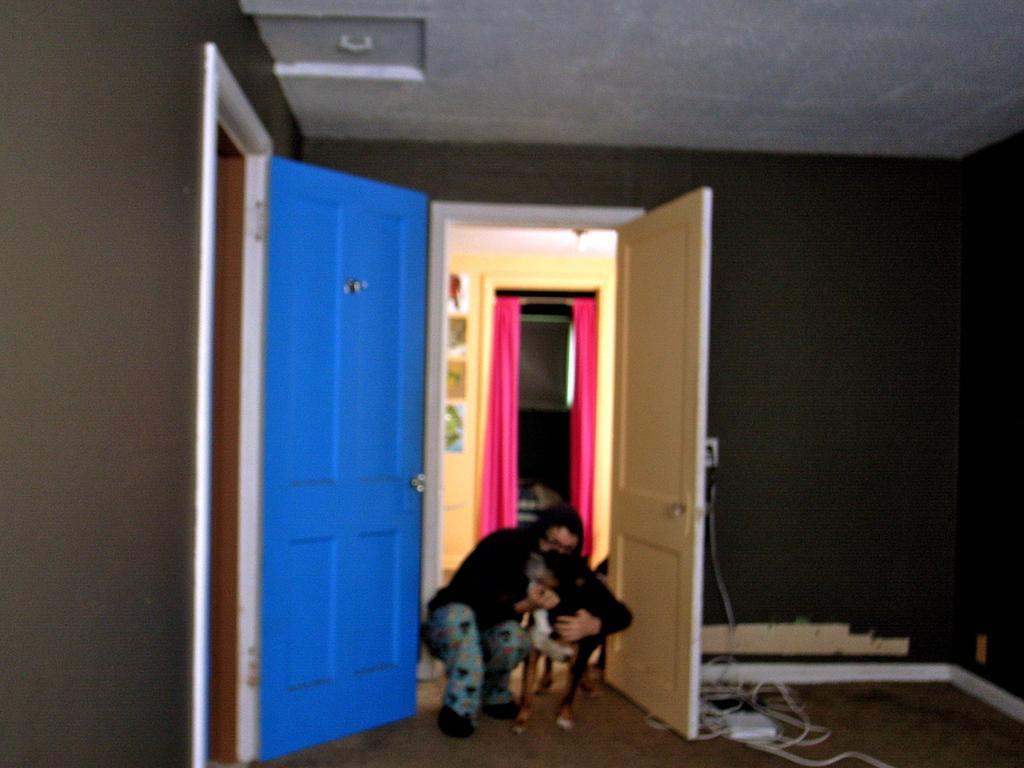Who or what can be seen in the image? There is a person and a dog in the image. What else is present in the image besides the person and the dog? There are wires, a device, walls, doors, a roof, curtains, posters, and some objects in the image. What type of list can be seen in the image? There is no list present in the image. What nation is represented by the flags in the image? There are no flags present in the image. 